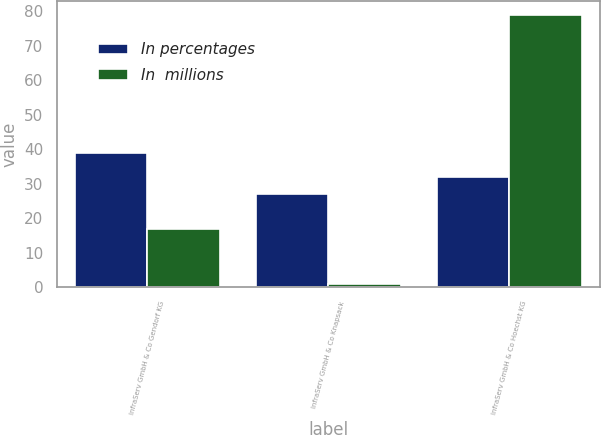<chart> <loc_0><loc_0><loc_500><loc_500><stacked_bar_chart><ecel><fcel>InfraServ GmbH & Co Gendorf KG<fcel>InfraServ GmbH & Co Knapsack<fcel>InfraServ GmbH & Co Hoechst KG<nl><fcel>In percentages<fcel>39<fcel>27<fcel>32<nl><fcel>In  millions<fcel>17<fcel>1<fcel>79<nl></chart> 